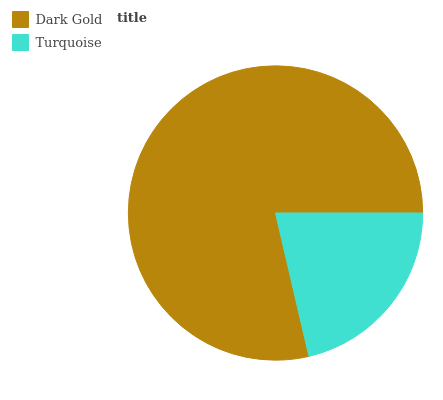Is Turquoise the minimum?
Answer yes or no. Yes. Is Dark Gold the maximum?
Answer yes or no. Yes. Is Turquoise the maximum?
Answer yes or no. No. Is Dark Gold greater than Turquoise?
Answer yes or no. Yes. Is Turquoise less than Dark Gold?
Answer yes or no. Yes. Is Turquoise greater than Dark Gold?
Answer yes or no. No. Is Dark Gold less than Turquoise?
Answer yes or no. No. Is Dark Gold the high median?
Answer yes or no. Yes. Is Turquoise the low median?
Answer yes or no. Yes. Is Turquoise the high median?
Answer yes or no. No. Is Dark Gold the low median?
Answer yes or no. No. 